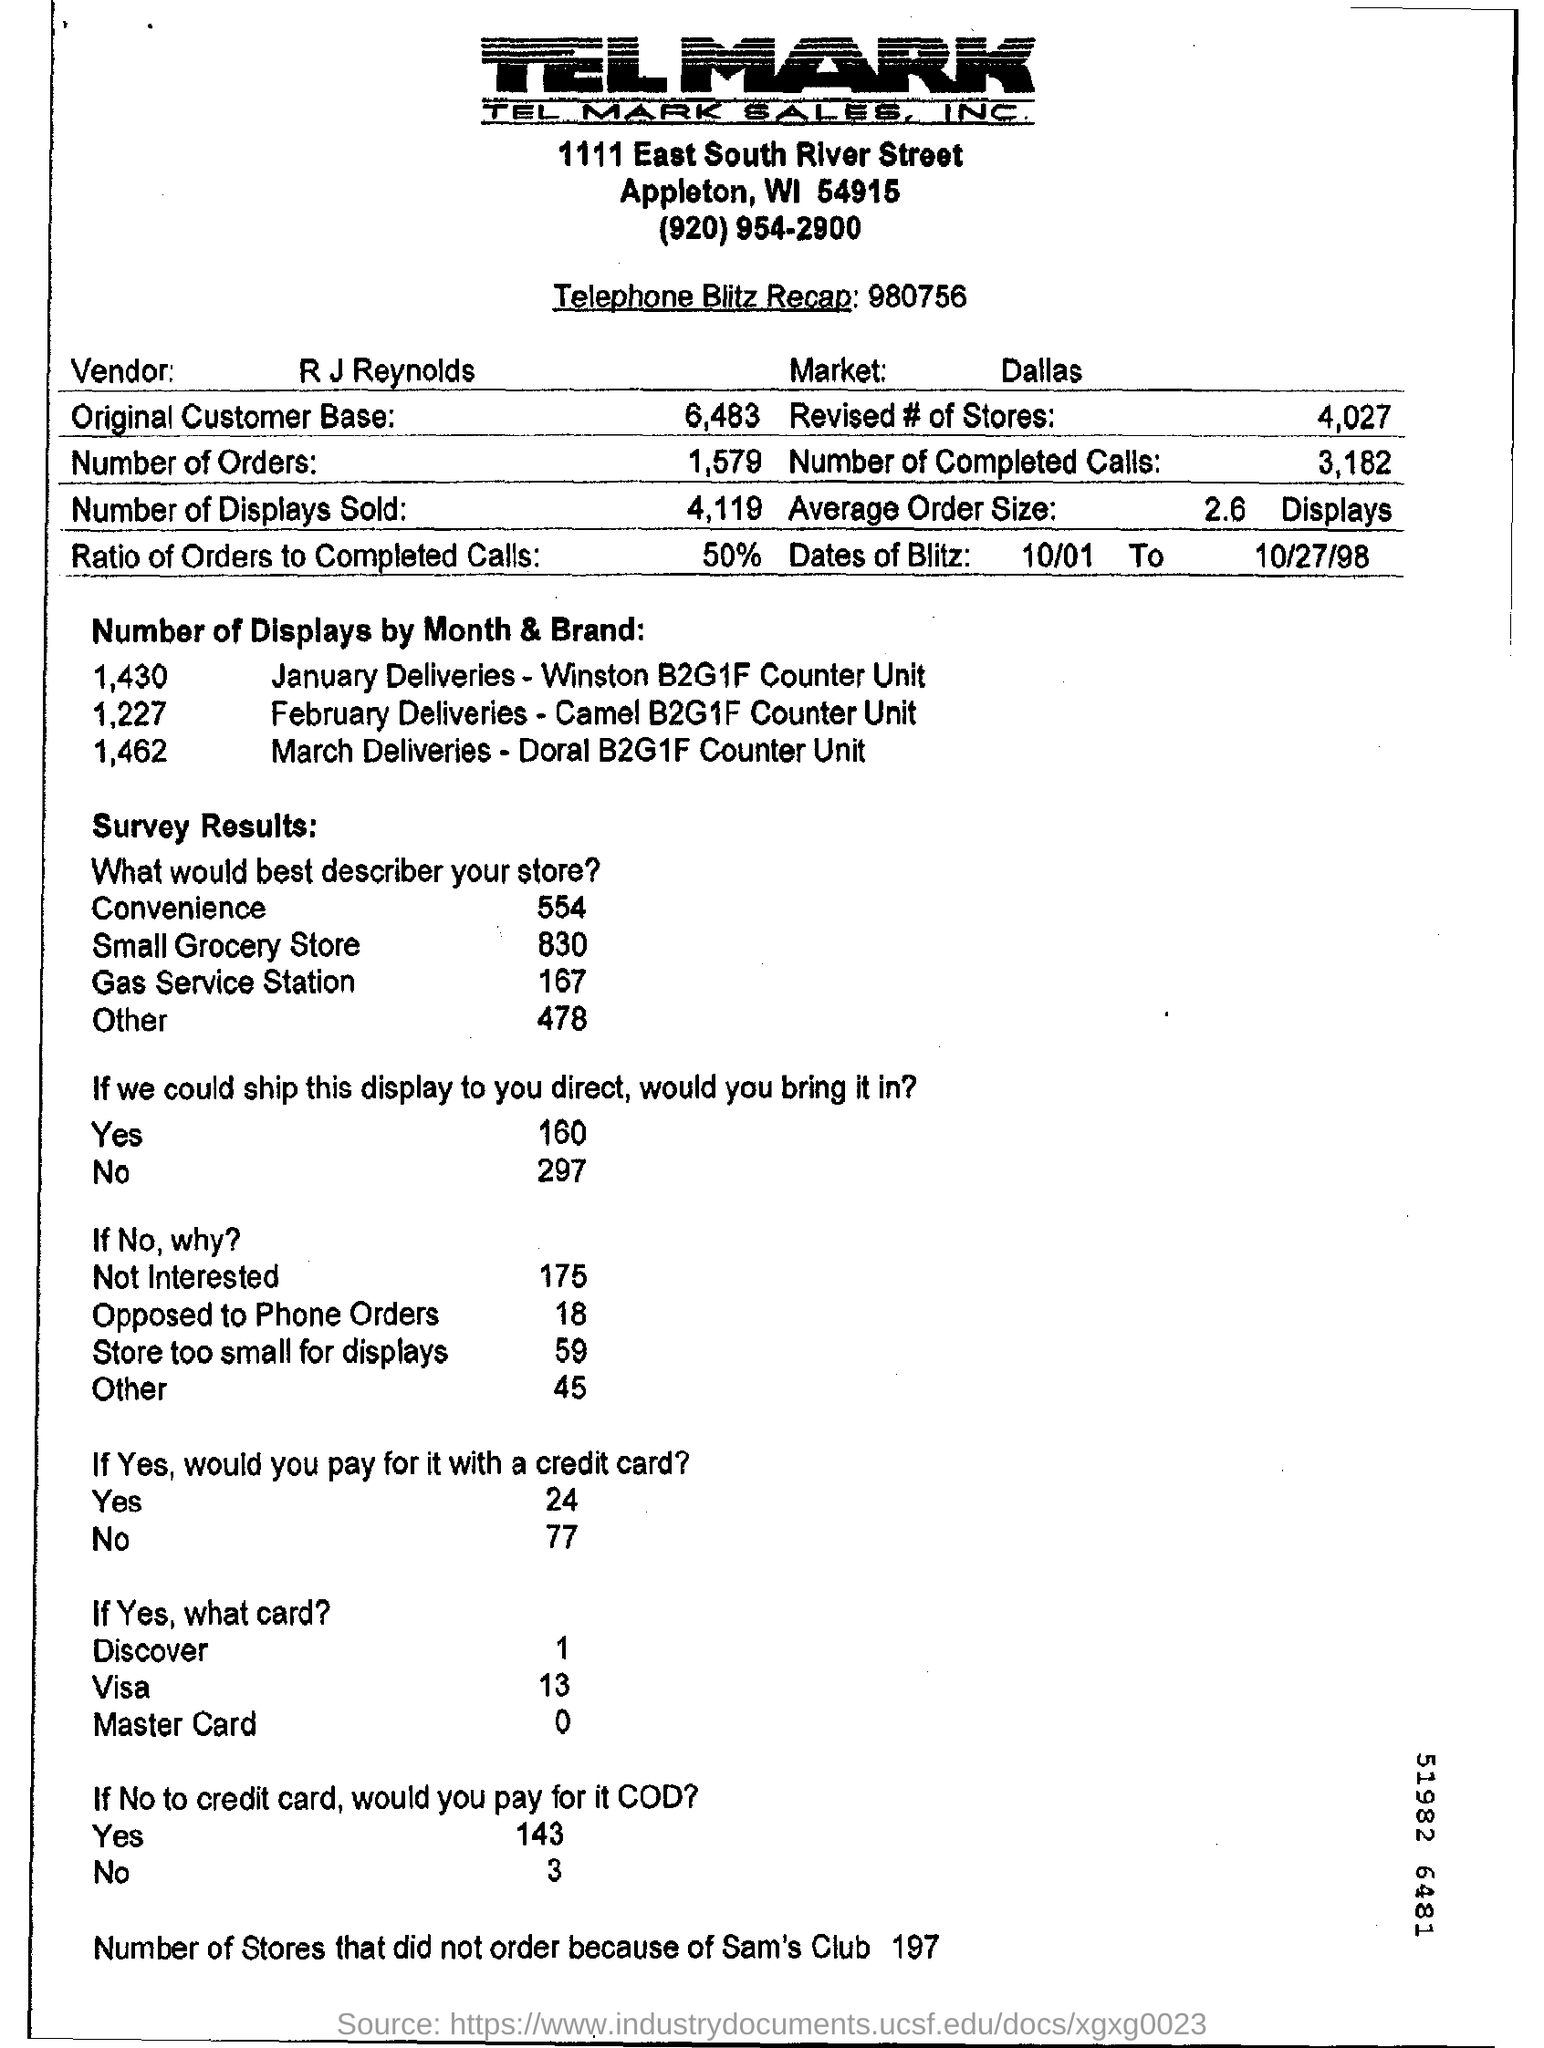Identify some key points in this picture. The vendor is named R J Reynolds. Approximately 50% of the cells have been completed. Out of the stores that did not place an order due to Sam's Club, 197 stores did not do so. The revised number of stores is 4027. The number of displays and the brands for which this information is available are listed for a total of three months. 